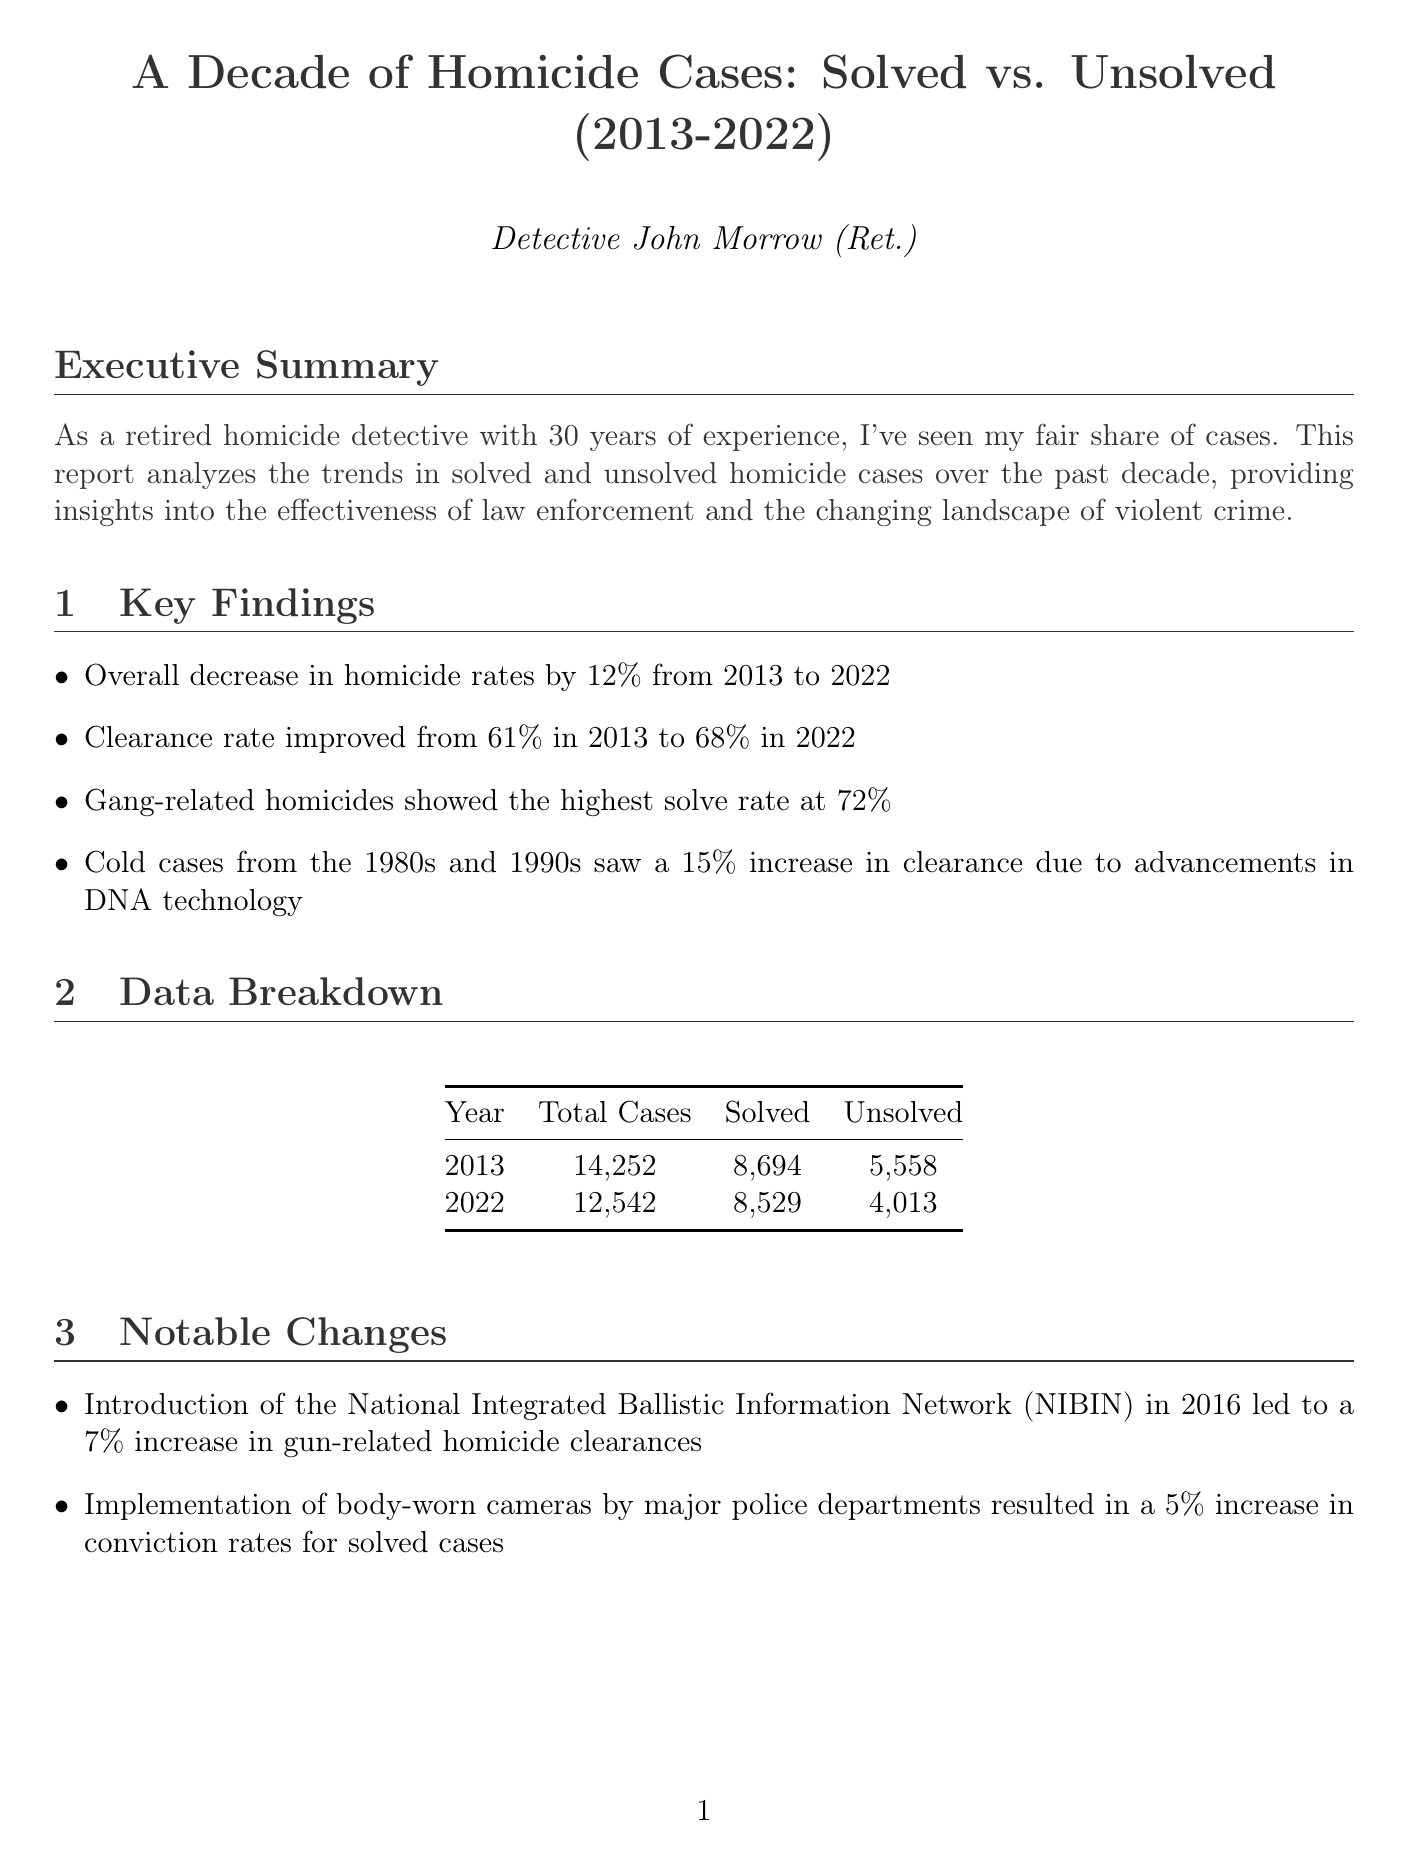What is the title of the report? The title of the report is specifically stated in the document, summarizing the main focus of the analysis.
Answer: A Decade of Homicide Cases: Solved vs. Unsolved (2013-2022) What was the clearance rate in 2013? The clearance rate for 2013 is provided in the key findings section as part of the statistics on homicide cases.
Answer: 61% How many gang-related homicides were solved? The report mentions that gang-related homicides had the highest solve rate, providing a specific percentage related to solve rates.
Answer: 72% What was the total number of homicides in 2022? The report includes a data breakdown with total homicide cases for the year 2022.
Answer: 12542 What notable change occurred in 2016? The document lists notable changes, and one specific change from 2016 is highlighted regarding a specific network.
Answer: Introduction of the National Integrated Ballistic Information Network (NIBIN) What year was the Zephyrhills Family Massacre solved? The report details individual challenging cases and their statuses, identifying the resolution year for a specific case.
Answer: 2021 What is one recommendation for improving homicide case resolution? The recommendations section provides specific actions aimed at enhancing homicide investigation efficiency.
Answer: Increase funding for forensic labs Compare the clearance rate improvement from 2013 to 2022. The report states the clearance rates for both years, indicating an improvement that demonstrates the trend over the decade analyzed.
Answer: Improved from 61% to 68% Who is the author of the report? Information about the author is provided at the end of the document, specifying their identity and background.
Answer: Detective John Morrow (Ret.) 